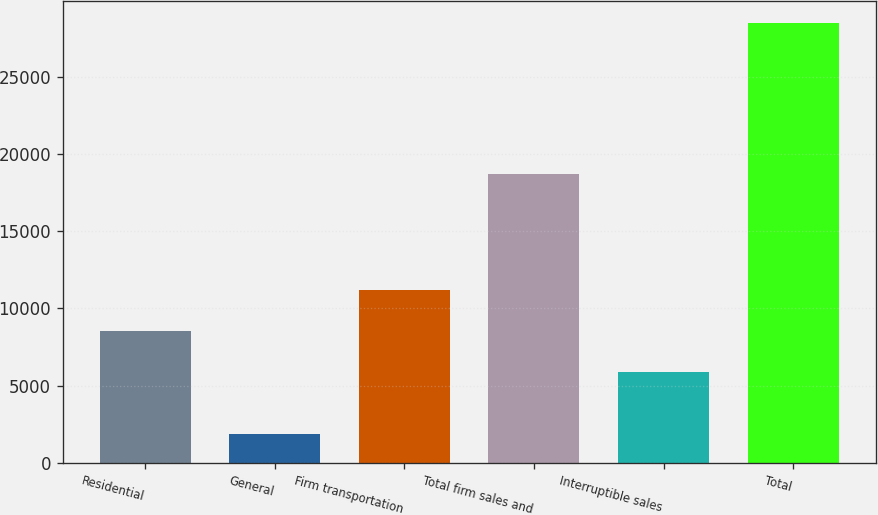<chart> <loc_0><loc_0><loc_500><loc_500><bar_chart><fcel>Residential<fcel>General<fcel>Firm transportation<fcel>Total firm sales and<fcel>Interruptible sales<fcel>Total<nl><fcel>8520.7<fcel>1892<fcel>11185.4<fcel>18708<fcel>5856<fcel>28539<nl></chart> 